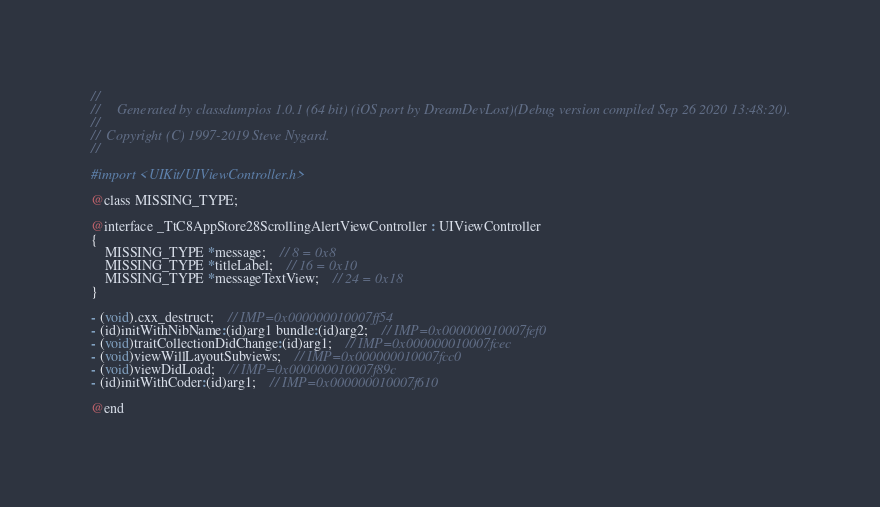Convert code to text. <code><loc_0><loc_0><loc_500><loc_500><_C_>//
//     Generated by classdumpios 1.0.1 (64 bit) (iOS port by DreamDevLost)(Debug version compiled Sep 26 2020 13:48:20).
//
//  Copyright (C) 1997-2019 Steve Nygard.
//

#import <UIKit/UIViewController.h>

@class MISSING_TYPE;

@interface _TtC8AppStore28ScrollingAlertViewController : UIViewController
{
    MISSING_TYPE *message;	// 8 = 0x8
    MISSING_TYPE *titleLabel;	// 16 = 0x10
    MISSING_TYPE *messageTextView;	// 24 = 0x18
}

- (void).cxx_destruct;	// IMP=0x000000010007ff54
- (id)initWithNibName:(id)arg1 bundle:(id)arg2;	// IMP=0x000000010007fef0
- (void)traitCollectionDidChange:(id)arg1;	// IMP=0x000000010007fcec
- (void)viewWillLayoutSubviews;	// IMP=0x000000010007fcc0
- (void)viewDidLoad;	// IMP=0x000000010007f89c
- (id)initWithCoder:(id)arg1;	// IMP=0x000000010007f610

@end

</code> 